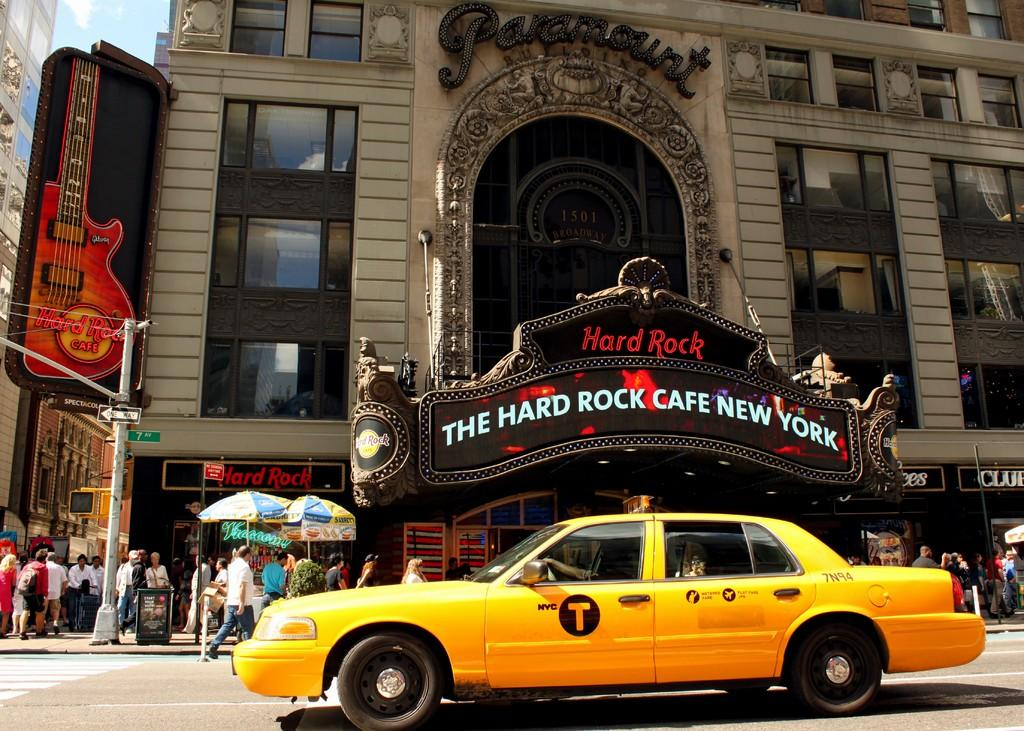<image>
Render a clear and concise summary of the photo. The Hard Rock Cafe in New York with a Taxi Cab # 7N94 in front of the building. 